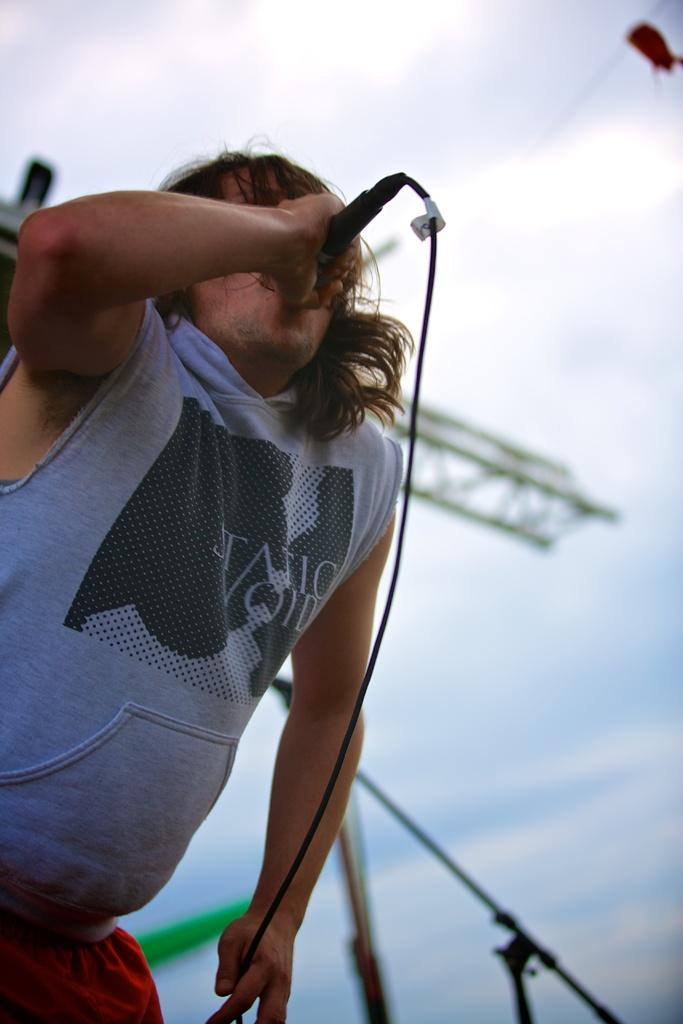What is the main subject of the image? There is a person in the image. What is the person holding in the image? The person is holding a microphone. Can you see a needle being used by the person in the image? No, there is no needle present in the image. Is there a giraffe in the image with the person? No, there is no giraffe present in the image. 